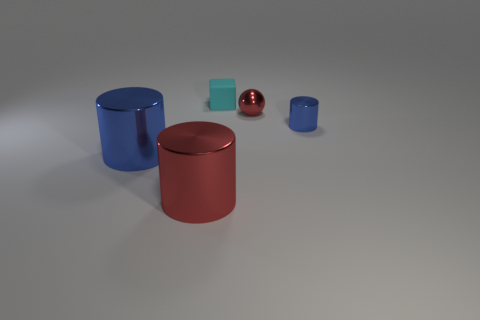Subtract all big metallic cylinders. How many cylinders are left? 1 Add 3 small green metallic things. How many objects exist? 8 Subtract all red cylinders. How many cylinders are left? 2 Subtract all spheres. How many objects are left? 4 Subtract 1 cubes. How many cubes are left? 0 Subtract all yellow balls. Subtract all purple blocks. How many balls are left? 1 Subtract all gray spheres. How many red blocks are left? 0 Subtract all big red balls. Subtract all cylinders. How many objects are left? 2 Add 5 red metallic things. How many red metallic things are left? 7 Add 2 cyan matte cubes. How many cyan matte cubes exist? 3 